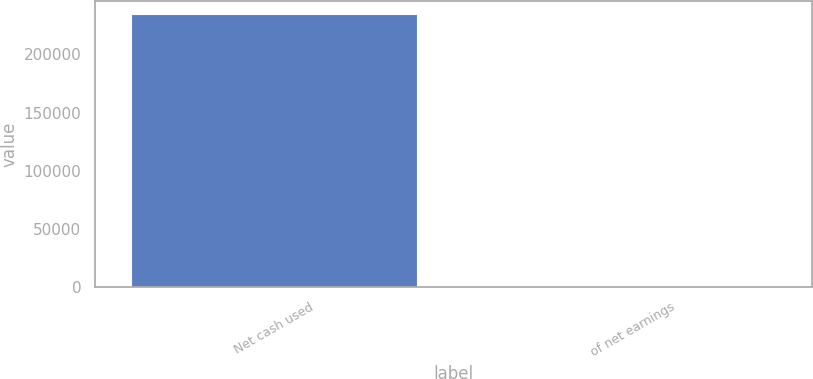Convert chart to OTSL. <chart><loc_0><loc_0><loc_500><loc_500><bar_chart><fcel>Net cash used<fcel>of net earnings<nl><fcel>234443<fcel>52.3<nl></chart> 